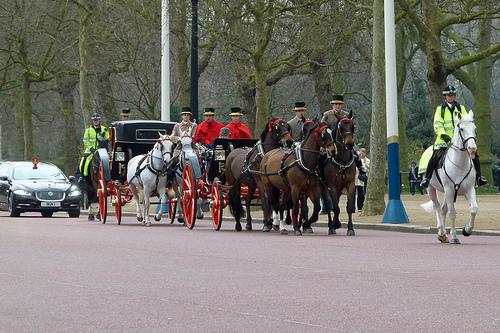Question: what color is the pavement?
Choices:
A. Grey.
B. White.
C. Red.
D. Brown.
Answer with the letter. Answer: A Question: how many kangaroos are in this?
Choices:
A. One.
B. Zero.
C. Two.
D. Three.
Answer with the letter. Answer: B Question: how many horses are readily visble here?
Choices:
A. Four.
B. Five.
C. Three.
D. Two.
Answer with the letter. Answer: B Question: how many carriages are in this image?
Choices:
A. Two.
B. One.
C. None.
D. Three.
Answer with the letter. Answer: A 